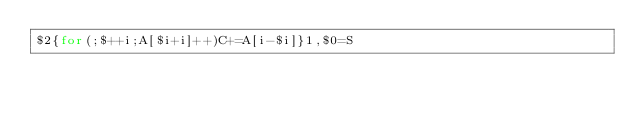<code> <loc_0><loc_0><loc_500><loc_500><_Awk_>$2{for(;$++i;A[$i+i]++)C+=A[i-$i]}1,$0=S</code> 